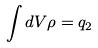<formula> <loc_0><loc_0><loc_500><loc_500>\int d V \rho = q _ { 2 }</formula> 